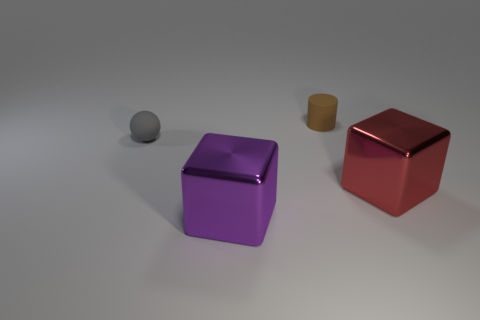What does the texture of the objects look like? The objects have a smooth texture with a matte-metallic finish, which gives them a realistic appearance as though they are made from metal. The lighting accentuates the texture, highlighting the contours and edges. 